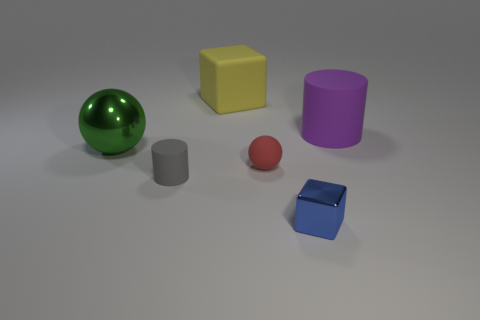What number of other objects are the same size as the blue object?
Keep it short and to the point. 2. How many large things are either yellow rubber objects or purple things?
Your response must be concise. 2. Does the big metal sphere have the same color as the matte cube?
Offer a very short reply. No. Are there more purple cylinders that are to the left of the purple cylinder than blue cubes that are behind the tiny red object?
Your answer should be compact. No. Is the color of the cylinder that is behind the green metallic sphere the same as the large ball?
Give a very brief answer. No. Is there any other thing of the same color as the large cylinder?
Your response must be concise. No. Are there more large yellow matte objects that are in front of the purple matte object than small cylinders?
Provide a short and direct response. No. Does the yellow matte thing have the same size as the red matte thing?
Provide a succinct answer. No. There is another object that is the same shape as the tiny red rubber thing; what material is it?
Your response must be concise. Metal. What number of blue things are either tiny blocks or large spheres?
Your answer should be compact. 1. 